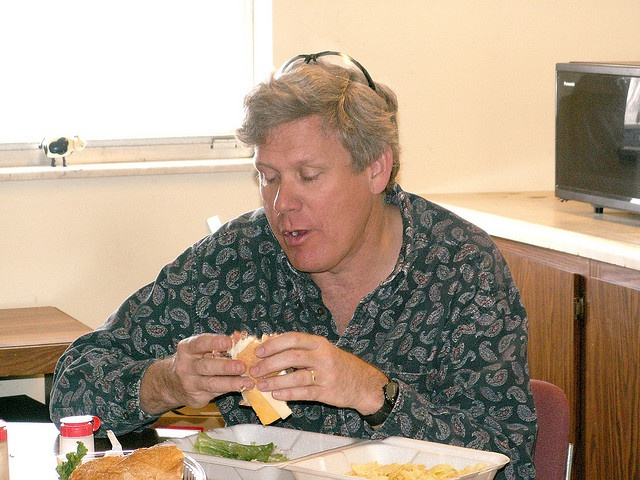Describe the objects in this image and their specific colors. I can see people in white, gray, black, and salmon tones, dining table in white, tan, and black tones, microwave in white, darkgreen, gray, black, and darkgray tones, dining table in white, tan, and olive tones, and chair in white, maroon, and brown tones in this image. 